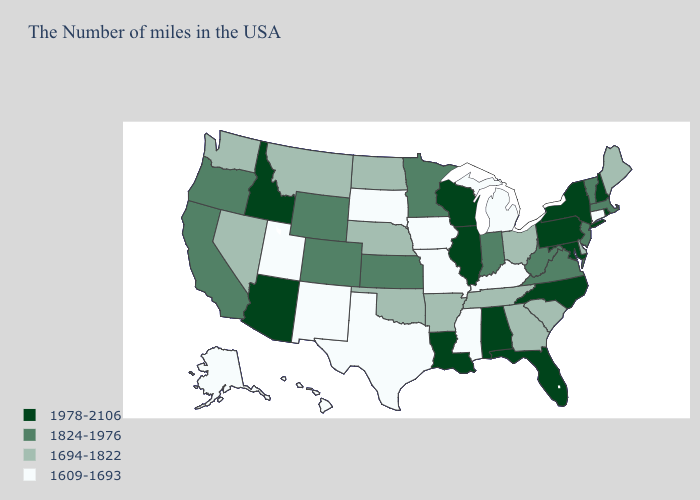What is the value of Michigan?
Be succinct. 1609-1693. What is the lowest value in states that border Delaware?
Be succinct. 1824-1976. Among the states that border Alabama , which have the highest value?
Concise answer only. Florida. Which states have the lowest value in the MidWest?
Quick response, please. Michigan, Missouri, Iowa, South Dakota. Name the states that have a value in the range 1824-1976?
Keep it brief. Massachusetts, Vermont, New Jersey, Virginia, West Virginia, Indiana, Minnesota, Kansas, Wyoming, Colorado, California, Oregon. Among the states that border Wyoming , does Utah have the lowest value?
Be succinct. Yes. What is the value of South Dakota?
Concise answer only. 1609-1693. What is the value of California?
Answer briefly. 1824-1976. Name the states that have a value in the range 1694-1822?
Give a very brief answer. Maine, Delaware, South Carolina, Ohio, Georgia, Tennessee, Arkansas, Nebraska, Oklahoma, North Dakota, Montana, Nevada, Washington. What is the lowest value in the MidWest?
Concise answer only. 1609-1693. What is the value of Iowa?
Concise answer only. 1609-1693. Name the states that have a value in the range 1978-2106?
Be succinct. Rhode Island, New Hampshire, New York, Maryland, Pennsylvania, North Carolina, Florida, Alabama, Wisconsin, Illinois, Louisiana, Arizona, Idaho. Name the states that have a value in the range 1609-1693?
Write a very short answer. Connecticut, Michigan, Kentucky, Mississippi, Missouri, Iowa, Texas, South Dakota, New Mexico, Utah, Alaska, Hawaii. What is the lowest value in the USA?
Write a very short answer. 1609-1693. What is the value of New Mexico?
Be succinct. 1609-1693. 